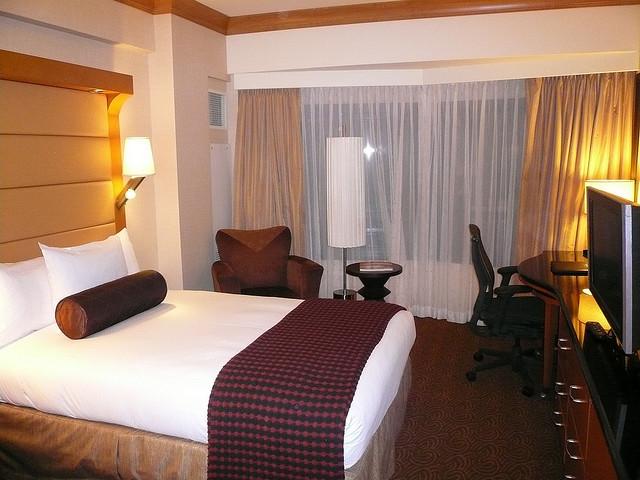How many pillows are on the bed?
Short answer required. 3. What is the cylindrical item on the bed?
Short answer required. Pillow. What color are the curtains?
Give a very brief answer. Tan. 